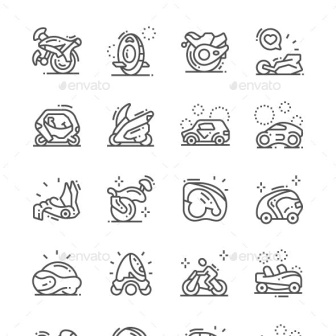How does the inclusion of both a car and a motorcycle in this set of icons reflect on personal transportation preferences? The inclusion of both a car and a motorcycle in the icons set reflects diverse personal transportation preferences and needs. Cars are often chosen for their practicality and safety, suitable for families or group travel, while motorcycles are preferred for their agility, fuel efficiency, and the sense of freedom they offer, ideal for individuals or enthusiasts seeking a more engaging travel experience. 